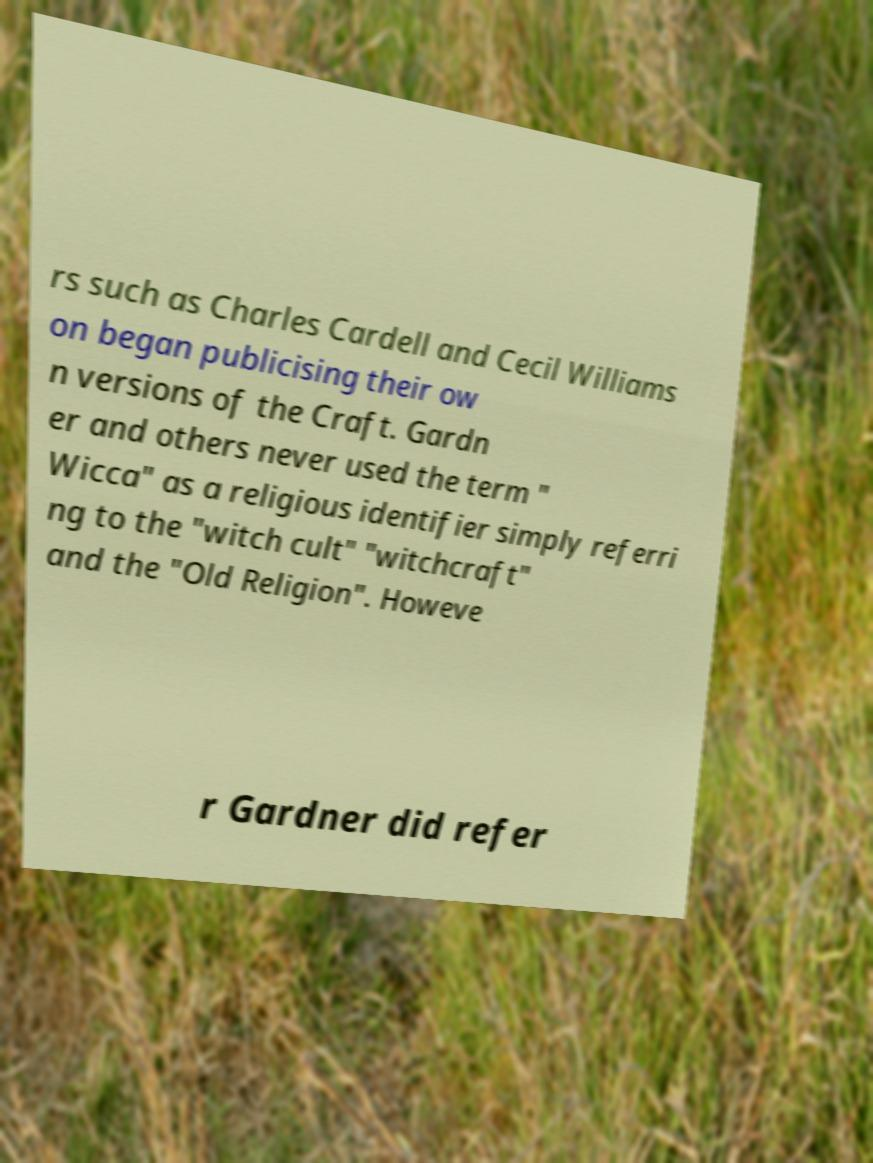Can you read and provide the text displayed in the image?This photo seems to have some interesting text. Can you extract and type it out for me? rs such as Charles Cardell and Cecil Williams on began publicising their ow n versions of the Craft. Gardn er and others never used the term " Wicca" as a religious identifier simply referri ng to the "witch cult" "witchcraft" and the "Old Religion". Howeve r Gardner did refer 